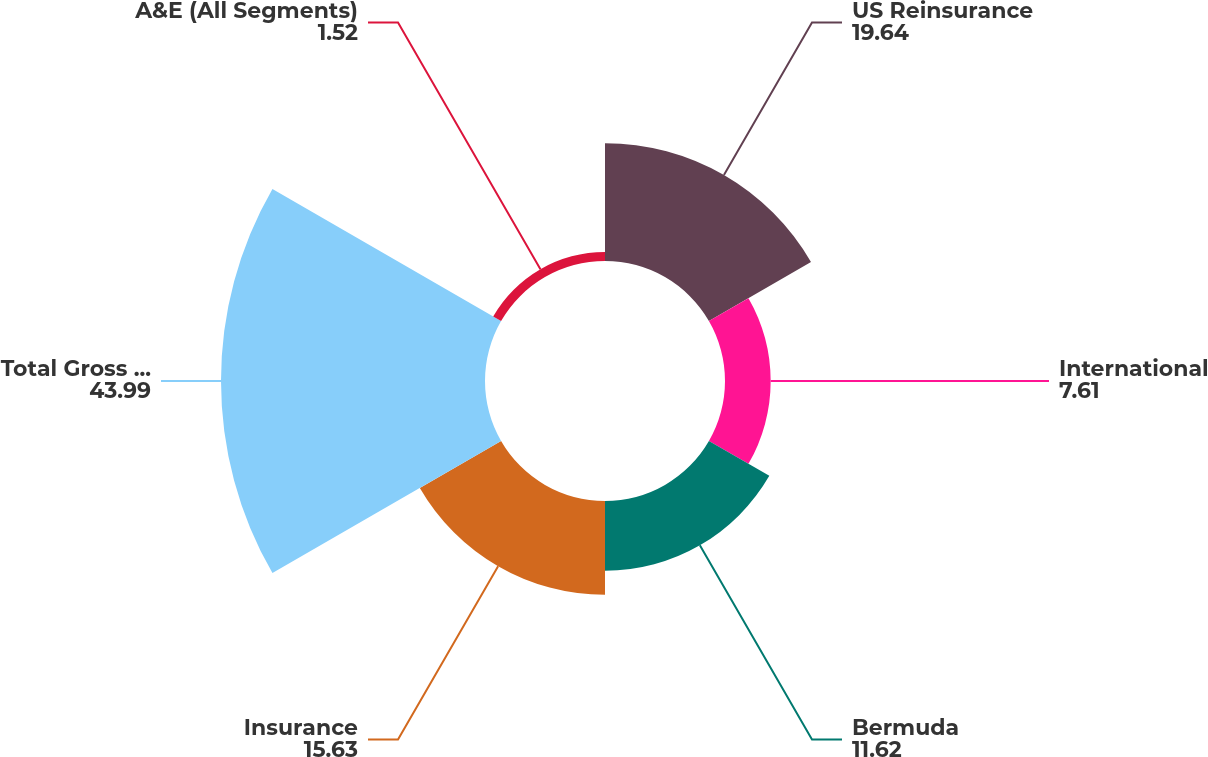Convert chart to OTSL. <chart><loc_0><loc_0><loc_500><loc_500><pie_chart><fcel>US Reinsurance<fcel>International<fcel>Bermuda<fcel>Insurance<fcel>Total Gross Reserves<fcel>A&E (All Segments)<nl><fcel>19.64%<fcel>7.61%<fcel>11.62%<fcel>15.63%<fcel>43.99%<fcel>1.52%<nl></chart> 